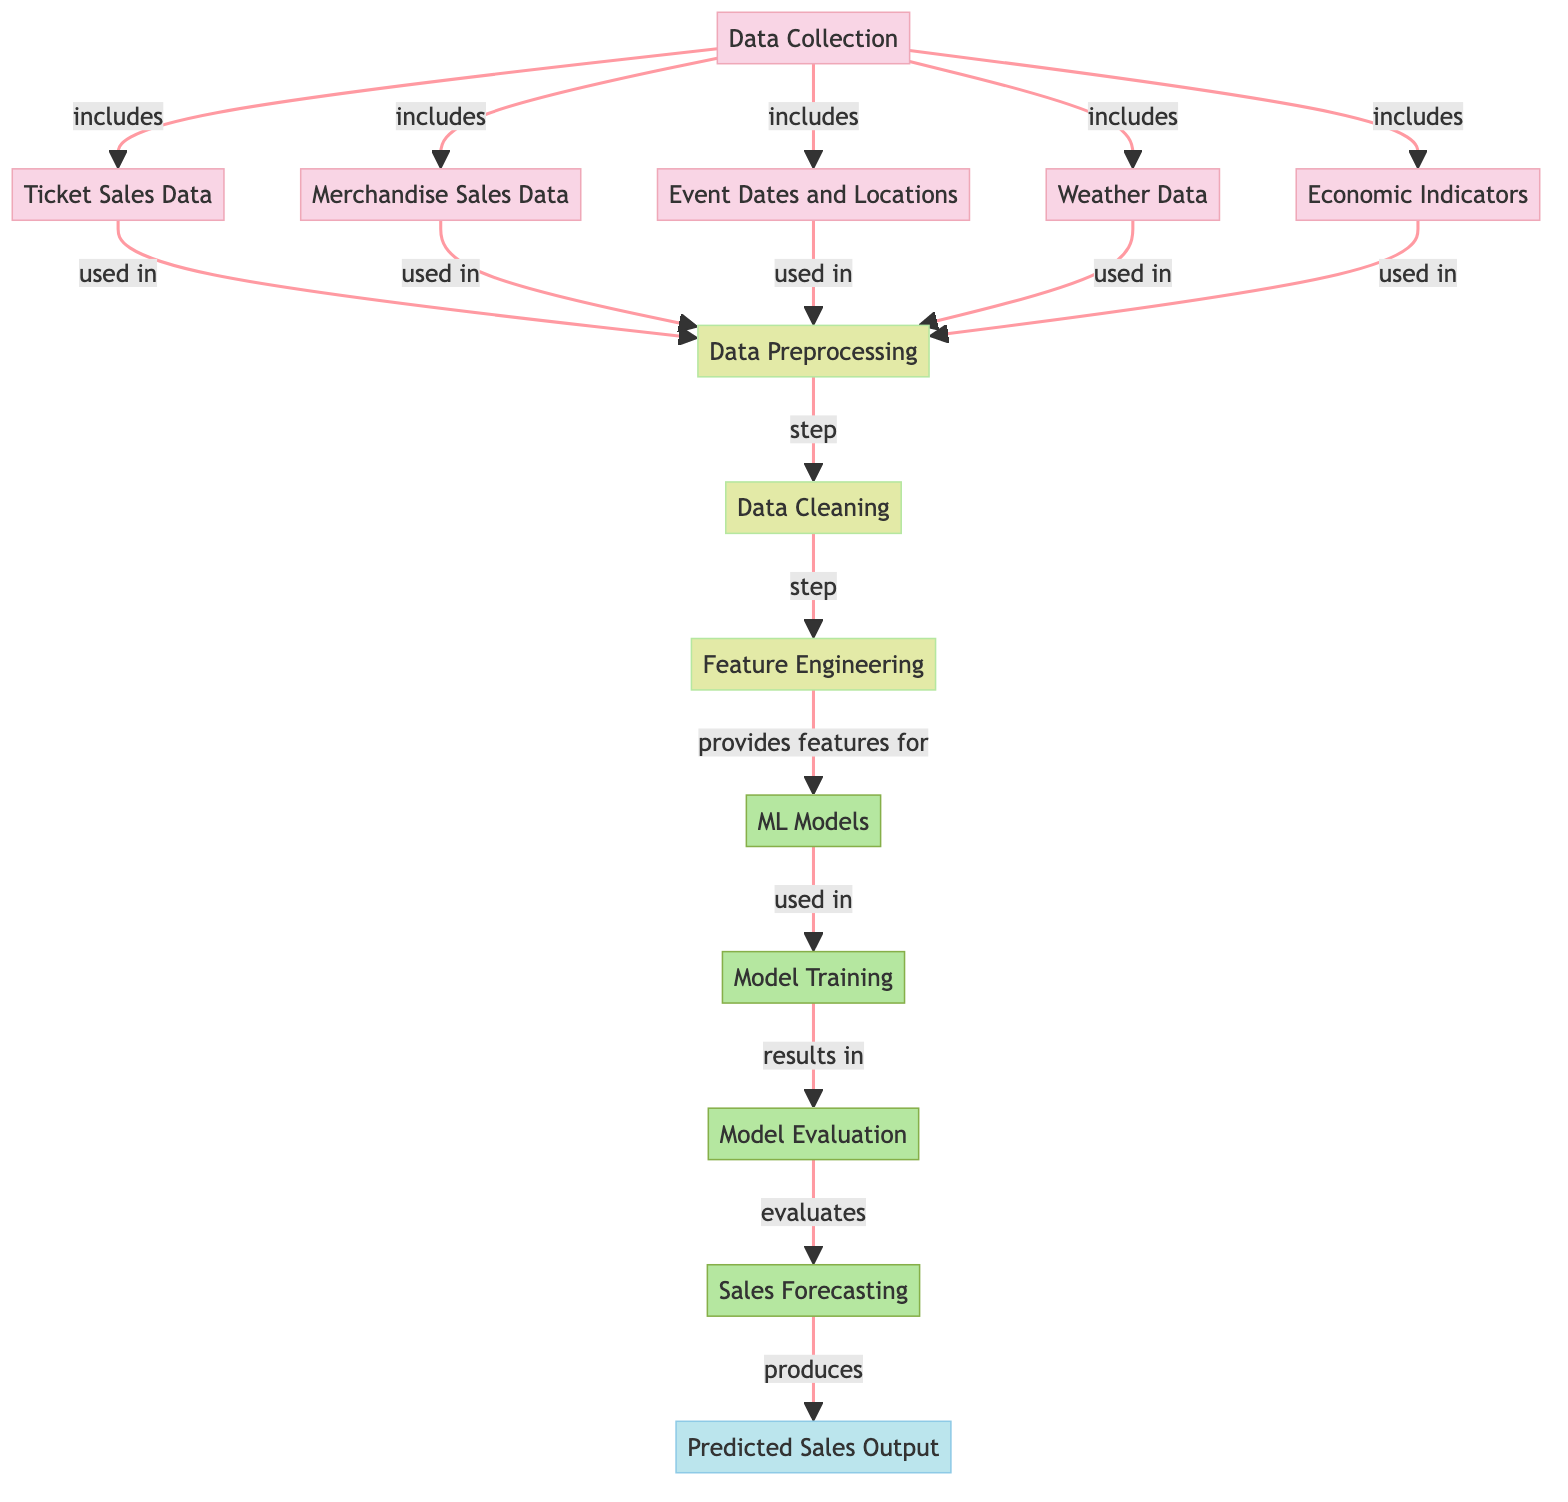What data is included in the data collection? The "Data Collection" node has arrows pointing towards several other data nodes: "Ticket Sales Data," "Merchandise Sales Data," "Event Dates and Locations," "Weather Data," and "Economic Indicators." This indicates that all these elements are part of the data collection process.
Answer: Ticket Sales Data, Merchandise Sales Data, Event Dates and Locations, Weather Data, Economic Indicators How many nodes are related to preprocessing? The "preprocessing" node has five nodes feeding into it, namely "Ticket Sales Data," "Merchandise Sales Data," "Event Dates and Locations," "Weather Data," and "Economic Indicators." Therefore, there are five nodes directly related to the preprocessing step.
Answer: Five What follows after data cleaning in the process? After the "Data Cleaning" node, there is only one outgoing arrow leading to the "Feature Engineering" node, indicating that feature engineering is the next step following data cleaning.
Answer: Feature Engineering Which node produces the final output? The diagram shows an output node labeled "Predicted Sales Output," which is the result of the entire process flowing downstream from the forecasting model. Thus, this node is the one that produces the final output of the model.
Answer: Predicted Sales Output What connects feature engineering to the machine learning models? The "Feature Engineering" node has an arrow pointing towards the "ML Models" node. This indicates that the features created during feature engineering are used as inputs for the machine learning models.
Answer: Provides features for After model evaluation, which process comes next? Following the "Model Evaluation" node, there is a connection leading to the "Sales Forecasting" node. This signifies that forecasting is the subsequent process after the model has been evaluated.
Answer: Sales Forecasting How does economic data influence the process? The "Economic Indicators" node feeds into the "Preprocessing" step, indicating that economic data is processed along with other data collections before proceeding to model training and evaluation.
Answer: Used in preprocessing What is the main focus of the "Forecasting" node? The "Forecasting" node directly leads to the "Predicted Sales Output," highlighting that its primary aim is to generate predictions based on the model outcomes derived from the previous steps.
Answer: Produces predicted sales What type of diagram is this? The diagram represents a flowchart that outlines the machine learning process for sales forecasting specifically geared toward analyzing music merchandise sales at events.
Answer: Flowchart 